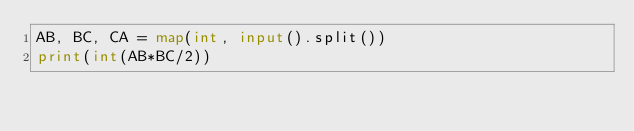<code> <loc_0><loc_0><loc_500><loc_500><_Python_>AB, BC, CA = map(int, input().split())
print(int(AB*BC/2))</code> 